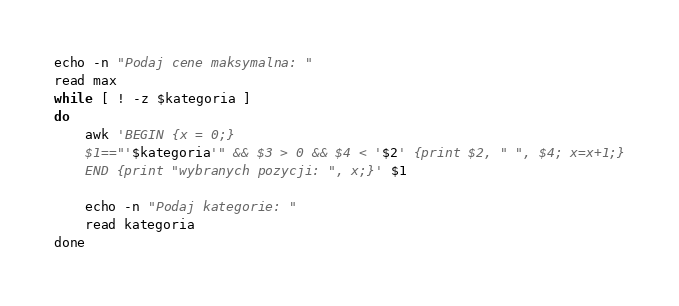Convert code to text. <code><loc_0><loc_0><loc_500><loc_500><_Awk_>echo -n "Podaj cene maksymalna: "
read max
while [ ! -z $kategoria ]
do
    awk 'BEGIN {x = 0;}
    $1=="'$kategoria'" && $3 > 0 && $4 < '$2' {print $2, " ", $4; x=x+1;}
    END {print "wybranych pozycji: ", x;}' $1

    echo -n "Podaj kategorie: "
    read kategoria
done

</code> 